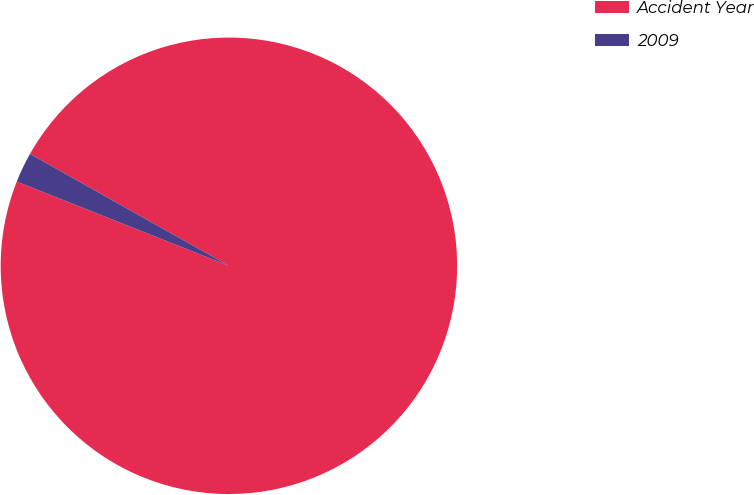<chart> <loc_0><loc_0><loc_500><loc_500><pie_chart><fcel>Accident Year<fcel>2009<nl><fcel>97.86%<fcel>2.14%<nl></chart> 